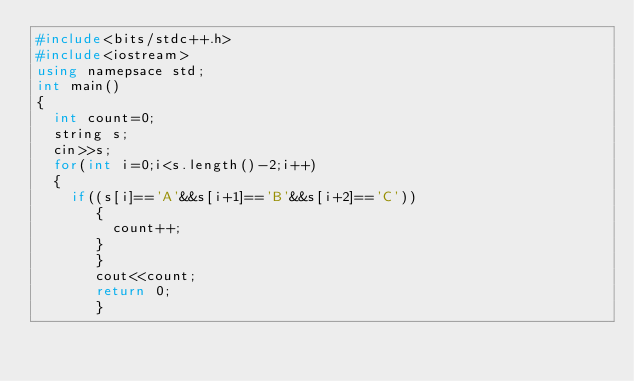<code> <loc_0><loc_0><loc_500><loc_500><_C++_>#include<bits/stdc++.h>
#include<iostream>
using namepsace std;
int main()
{
  int count=0;
  string s;
  cin>>s;
  for(int i=0;i<s.length()-2;i++)
  {
    if((s[i]=='A'&&s[i+1]=='B'&&s[i+2]=='C'))
       {
         count++;
       }
       }
       cout<<count;
       return 0;
       }</code> 